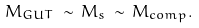Convert formula to latex. <formula><loc_0><loc_0><loc_500><loc_500>M _ { G U T } \, \sim \, M _ { s } \, \sim \, M _ { c o m p } .</formula> 